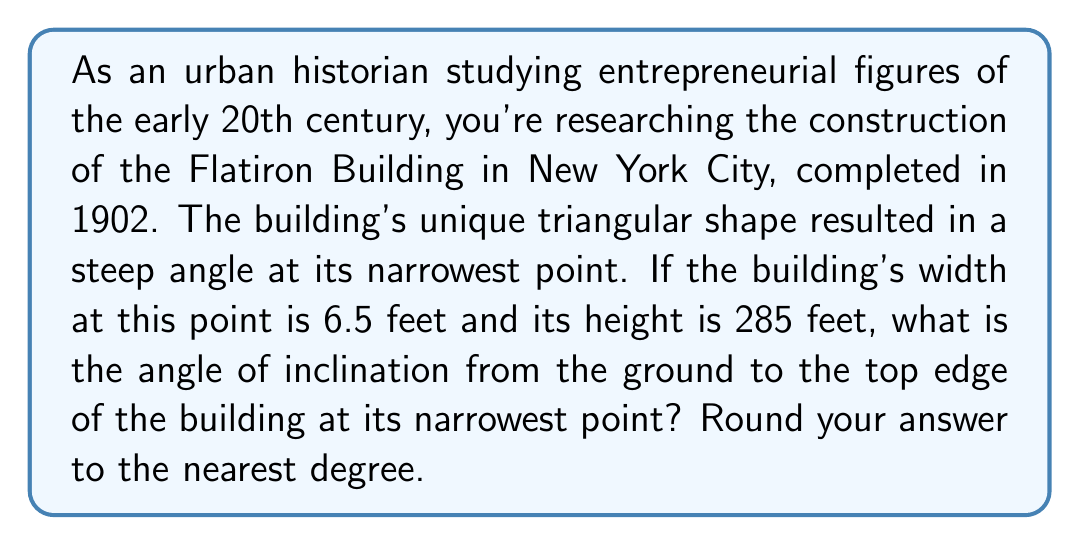Can you solve this math problem? To solve this problem, we need to use trigonometry, specifically the arctangent function. Let's break it down step-by-step:

1. Visualize the problem:
   [asy]
   import geometry;
   
   size(200);
   
   pair A = (0,0), B = (6.5,0), C = (0,285);
   
   draw(A--B--C--A);
   
   label("6.5 ft", (A+B)/2, S);
   label("285 ft", (A+C)/2, W);
   label("θ", A, SE);
   
   draw(rightanglemark(A,B,C,2));
   [/asy]

2. Identify the trigonometric relationship:
   We have a right-angled triangle where:
   - The adjacent side (width) is 6.5 feet
   - The opposite side (height) is 285 feet
   - We need to find the angle θ

3. Use the arctangent function:
   $$\theta = \arctan(\frac{\text{opposite}}{\text{adjacent}})$$

4. Plug in the values:
   $$\theta = \arctan(\frac{285}{6.5})$$

5. Calculate:
   $$\theta = \arctan(43.8461538...)$$
   $$\theta ≈ 88.69°$$

6. Round to the nearest degree:
   $$\theta ≈ 89°$$

This extremely steep angle explains why the Flatiron Building appeared so striking and innovative for its time, challenging conventional architectural norms and showcasing the entrepreneurial spirit of early 20th-century urban development.
Answer: $89°$ 